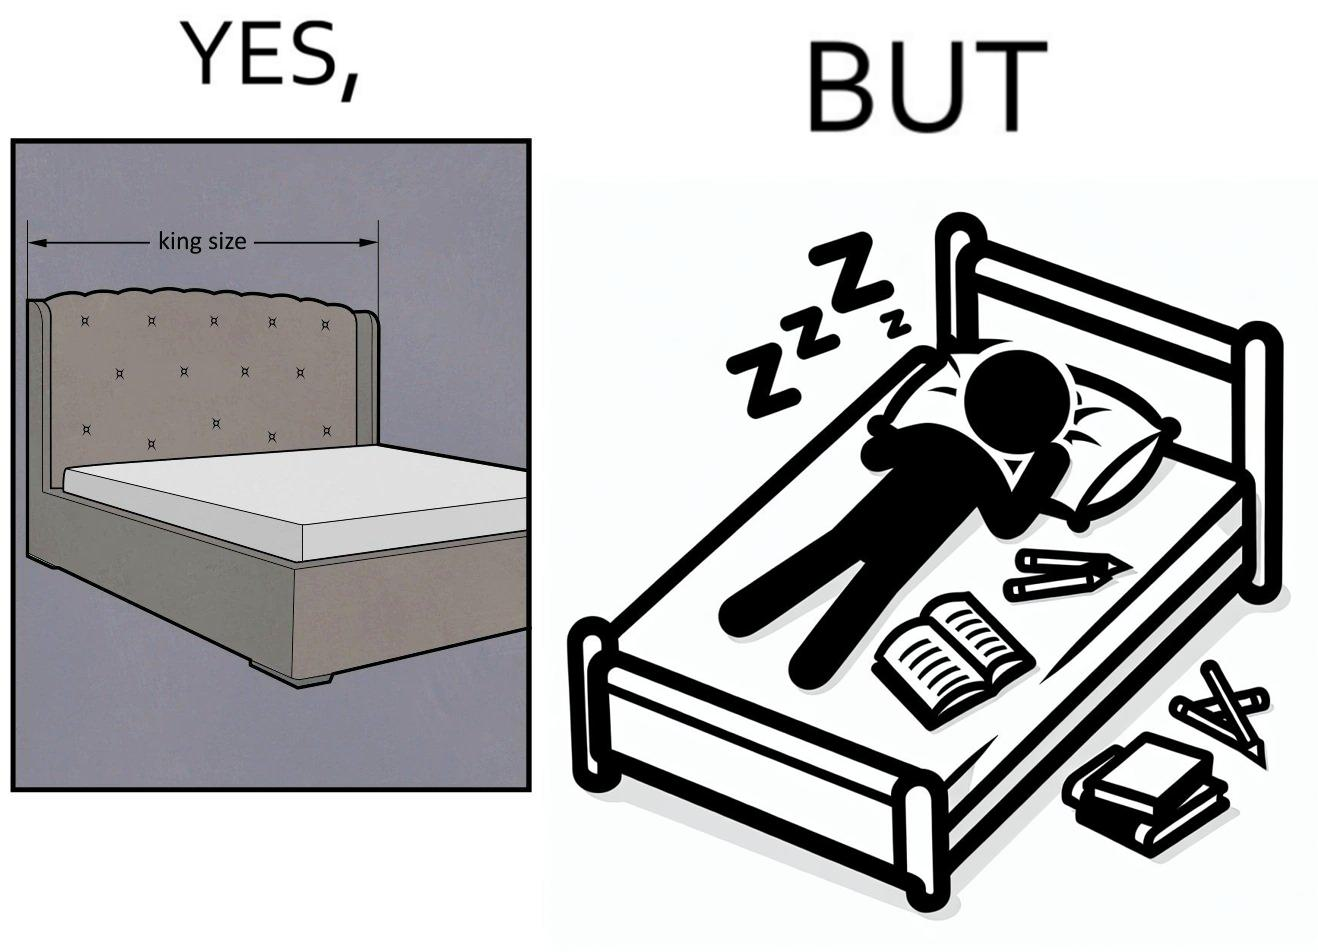What does this image depict? Although the person has purchased a king size bed, but only less than half of the space is used by the person for sleeping. 